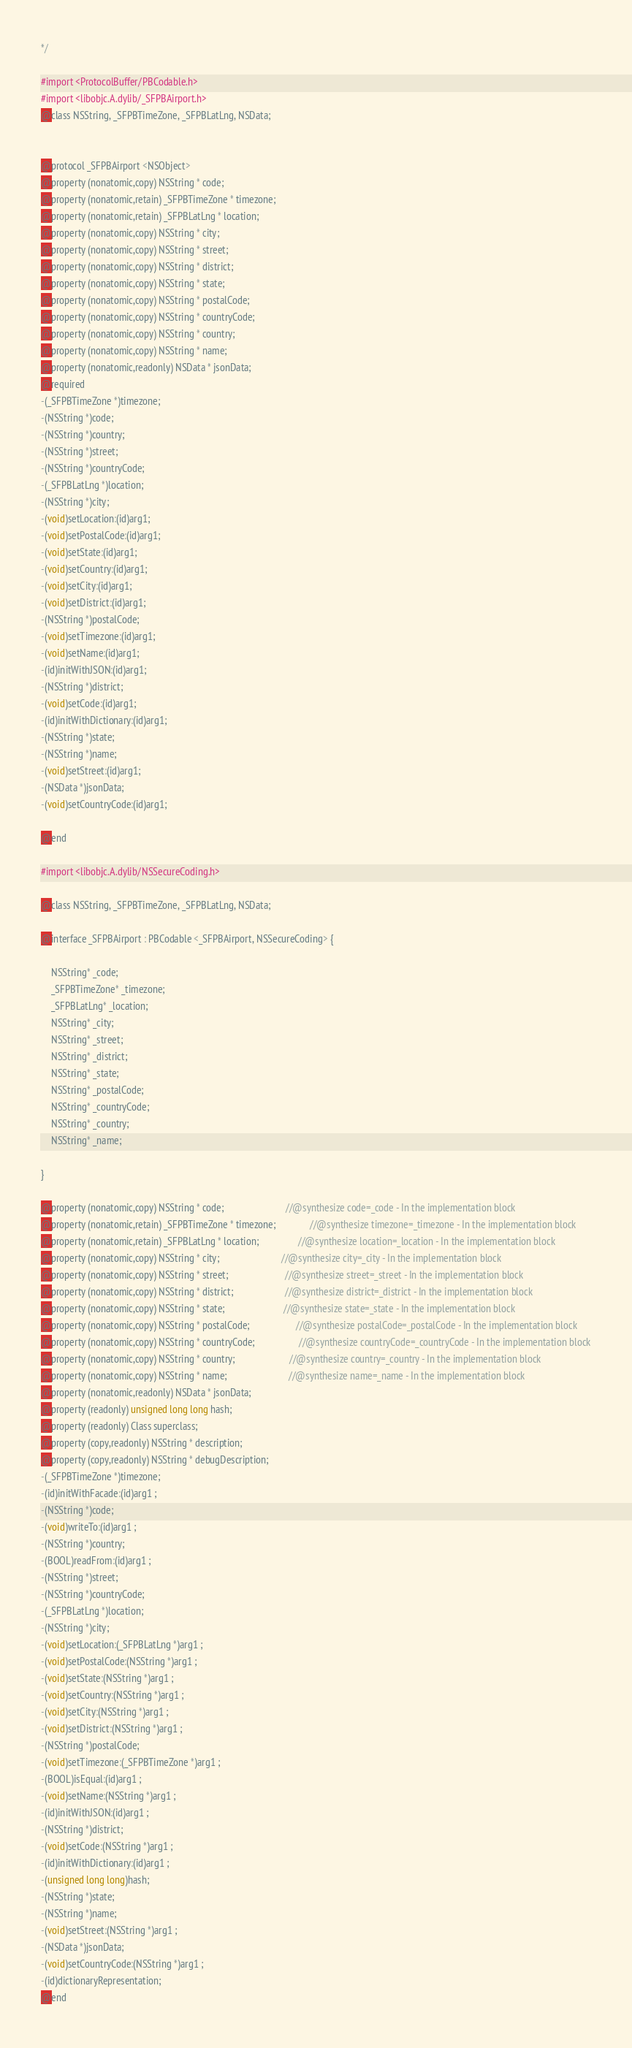Convert code to text. <code><loc_0><loc_0><loc_500><loc_500><_C_>*/

#import <ProtocolBuffer/PBCodable.h>
#import <libobjc.A.dylib/_SFPBAirport.h>
@class NSString, _SFPBTimeZone, _SFPBLatLng, NSData;


@protocol _SFPBAirport <NSObject>
@property (nonatomic,copy) NSString * code; 
@property (nonatomic,retain) _SFPBTimeZone * timezone; 
@property (nonatomic,retain) _SFPBLatLng * location; 
@property (nonatomic,copy) NSString * city; 
@property (nonatomic,copy) NSString * street; 
@property (nonatomic,copy) NSString * district; 
@property (nonatomic,copy) NSString * state; 
@property (nonatomic,copy) NSString * postalCode; 
@property (nonatomic,copy) NSString * countryCode; 
@property (nonatomic,copy) NSString * country; 
@property (nonatomic,copy) NSString * name; 
@property (nonatomic,readonly) NSData * jsonData; 
@required
-(_SFPBTimeZone *)timezone;
-(NSString *)code;
-(NSString *)country;
-(NSString *)street;
-(NSString *)countryCode;
-(_SFPBLatLng *)location;
-(NSString *)city;
-(void)setLocation:(id)arg1;
-(void)setPostalCode:(id)arg1;
-(void)setState:(id)arg1;
-(void)setCountry:(id)arg1;
-(void)setCity:(id)arg1;
-(void)setDistrict:(id)arg1;
-(NSString *)postalCode;
-(void)setTimezone:(id)arg1;
-(void)setName:(id)arg1;
-(id)initWithJSON:(id)arg1;
-(NSString *)district;
-(void)setCode:(id)arg1;
-(id)initWithDictionary:(id)arg1;
-(NSString *)state;
-(NSString *)name;
-(void)setStreet:(id)arg1;
-(NSData *)jsonData;
-(void)setCountryCode:(id)arg1;

@end

#import <libobjc.A.dylib/NSSecureCoding.h>

@class NSString, _SFPBTimeZone, _SFPBLatLng, NSData;

@interface _SFPBAirport : PBCodable <_SFPBAirport, NSSecureCoding> {

	NSString* _code;
	_SFPBTimeZone* _timezone;
	_SFPBLatLng* _location;
	NSString* _city;
	NSString* _street;
	NSString* _district;
	NSString* _state;
	NSString* _postalCode;
	NSString* _countryCode;
	NSString* _country;
	NSString* _name;

}

@property (nonatomic,copy) NSString * code;                         //@synthesize code=_code - In the implementation block
@property (nonatomic,retain) _SFPBTimeZone * timezone;              //@synthesize timezone=_timezone - In the implementation block
@property (nonatomic,retain) _SFPBLatLng * location;                //@synthesize location=_location - In the implementation block
@property (nonatomic,copy) NSString * city;                         //@synthesize city=_city - In the implementation block
@property (nonatomic,copy) NSString * street;                       //@synthesize street=_street - In the implementation block
@property (nonatomic,copy) NSString * district;                     //@synthesize district=_district - In the implementation block
@property (nonatomic,copy) NSString * state;                        //@synthesize state=_state - In the implementation block
@property (nonatomic,copy) NSString * postalCode;                   //@synthesize postalCode=_postalCode - In the implementation block
@property (nonatomic,copy) NSString * countryCode;                  //@synthesize countryCode=_countryCode - In the implementation block
@property (nonatomic,copy) NSString * country;                      //@synthesize country=_country - In the implementation block
@property (nonatomic,copy) NSString * name;                         //@synthesize name=_name - In the implementation block
@property (nonatomic,readonly) NSData * jsonData; 
@property (readonly) unsigned long long hash; 
@property (readonly) Class superclass; 
@property (copy,readonly) NSString * description; 
@property (copy,readonly) NSString * debugDescription; 
-(_SFPBTimeZone *)timezone;
-(id)initWithFacade:(id)arg1 ;
-(NSString *)code;
-(void)writeTo:(id)arg1 ;
-(NSString *)country;
-(BOOL)readFrom:(id)arg1 ;
-(NSString *)street;
-(NSString *)countryCode;
-(_SFPBLatLng *)location;
-(NSString *)city;
-(void)setLocation:(_SFPBLatLng *)arg1 ;
-(void)setPostalCode:(NSString *)arg1 ;
-(void)setState:(NSString *)arg1 ;
-(void)setCountry:(NSString *)arg1 ;
-(void)setCity:(NSString *)arg1 ;
-(void)setDistrict:(NSString *)arg1 ;
-(NSString *)postalCode;
-(void)setTimezone:(_SFPBTimeZone *)arg1 ;
-(BOOL)isEqual:(id)arg1 ;
-(void)setName:(NSString *)arg1 ;
-(id)initWithJSON:(id)arg1 ;
-(NSString *)district;
-(void)setCode:(NSString *)arg1 ;
-(id)initWithDictionary:(id)arg1 ;
-(unsigned long long)hash;
-(NSString *)state;
-(NSString *)name;
-(void)setStreet:(NSString *)arg1 ;
-(NSData *)jsonData;
-(void)setCountryCode:(NSString *)arg1 ;
-(id)dictionaryRepresentation;
@end

</code> 